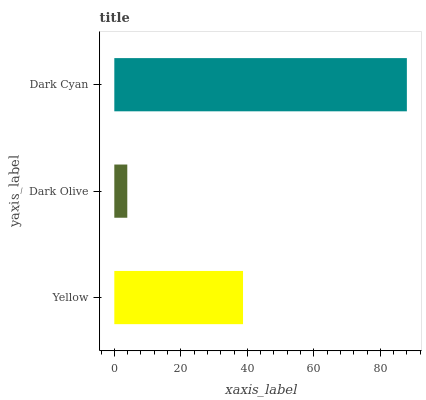Is Dark Olive the minimum?
Answer yes or no. Yes. Is Dark Cyan the maximum?
Answer yes or no. Yes. Is Dark Cyan the minimum?
Answer yes or no. No. Is Dark Olive the maximum?
Answer yes or no. No. Is Dark Cyan greater than Dark Olive?
Answer yes or no. Yes. Is Dark Olive less than Dark Cyan?
Answer yes or no. Yes. Is Dark Olive greater than Dark Cyan?
Answer yes or no. No. Is Dark Cyan less than Dark Olive?
Answer yes or no. No. Is Yellow the high median?
Answer yes or no. Yes. Is Yellow the low median?
Answer yes or no. Yes. Is Dark Cyan the high median?
Answer yes or no. No. Is Dark Cyan the low median?
Answer yes or no. No. 